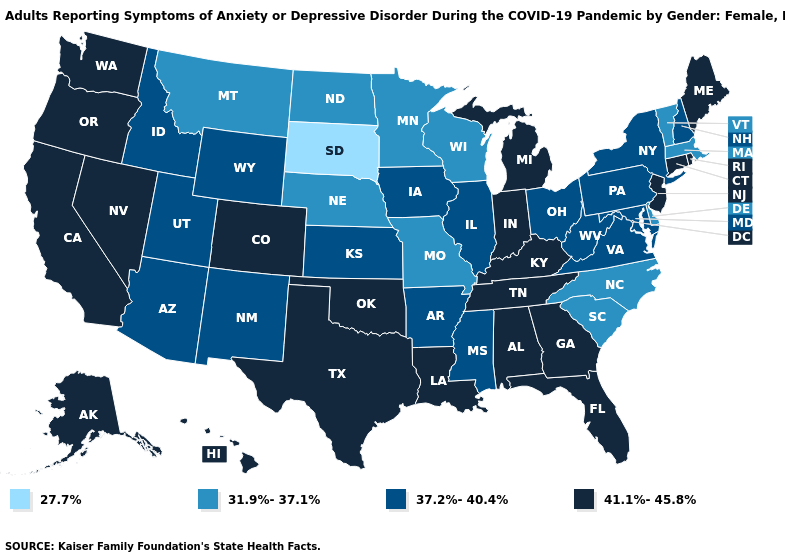Which states have the lowest value in the USA?
Write a very short answer. South Dakota. Does the map have missing data?
Answer briefly. No. Which states hav the highest value in the South?
Give a very brief answer. Alabama, Florida, Georgia, Kentucky, Louisiana, Oklahoma, Tennessee, Texas. What is the lowest value in the Northeast?
Concise answer only. 31.9%-37.1%. Among the states that border Maine , which have the lowest value?
Short answer required. New Hampshire. What is the value of Ohio?
Give a very brief answer. 37.2%-40.4%. What is the value of Colorado?
Give a very brief answer. 41.1%-45.8%. What is the value of Wyoming?
Answer briefly. 37.2%-40.4%. What is the value of Nevada?
Give a very brief answer. 41.1%-45.8%. Name the states that have a value in the range 37.2%-40.4%?
Give a very brief answer. Arizona, Arkansas, Idaho, Illinois, Iowa, Kansas, Maryland, Mississippi, New Hampshire, New Mexico, New York, Ohio, Pennsylvania, Utah, Virginia, West Virginia, Wyoming. How many symbols are there in the legend?
Quick response, please. 4. What is the value of Oregon?
Answer briefly. 41.1%-45.8%. Which states have the lowest value in the USA?
Quick response, please. South Dakota. Name the states that have a value in the range 37.2%-40.4%?
Give a very brief answer. Arizona, Arkansas, Idaho, Illinois, Iowa, Kansas, Maryland, Mississippi, New Hampshire, New Mexico, New York, Ohio, Pennsylvania, Utah, Virginia, West Virginia, Wyoming. Does New Hampshire have a lower value than Ohio?
Be succinct. No. 